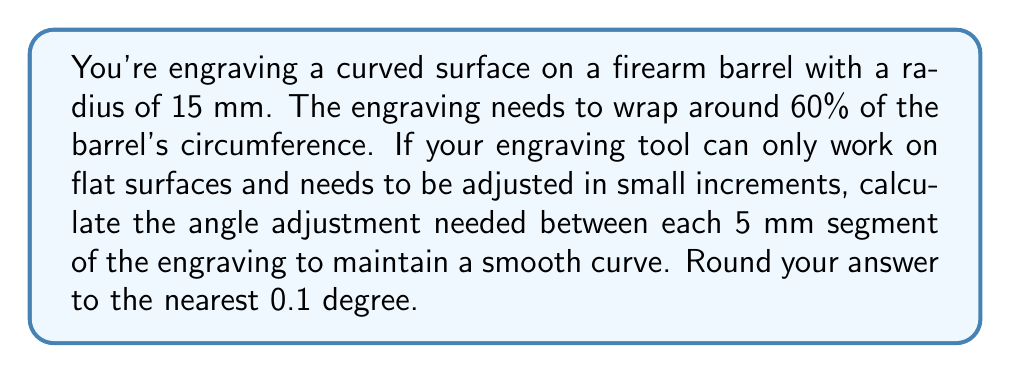Can you answer this question? To solve this problem, we need to follow these steps:

1) First, calculate the total arc length of the engraving:
   Circumference of barrel = $2\pi r = 2\pi(15) = 30\pi$ mm
   60% of circumference = $0.6 \times 30\pi = 18\pi$ mm

2) We need to divide this into 5 mm segments. Calculate the number of segments:
   Number of segments = $\frac{18\pi}{5} = 3.6\pi \approx 11.31$
   We'll round this to 11 segments for practical purposes.

3) Now, we need to find the central angle corresponding to these 11 segments:
   Total central angle = $0.6 \times 360° = 216°$ (since the engraving covers 60% of the circumference)

4) The angle adjustment between each segment will be:
   Angle per segment = $\frac{216°}{11} = 19.64°$

5) However, this is the central angle. We need the angle adjustment for the engraving tool, which is the complement of half this angle:

   $$\text{Tool adjustment angle} = 90° - \frac{19.64°}{2} = 80.18°$$

Therefore, the angle adjustment needed between each 5 mm segment is approximately 80.2°.

[asy]
import geometry;

size(200);
pair O = (0,0);
real r = 5;
draw(circle(O,r));
draw(O--(-r,0), dashed);
draw(O--(r*cos(19.64), r*sin(19.64)));
draw(arc(O, (-r,0), (r*cos(19.64), r*sin(19.64))), blue);
label("$19.64°$", (0.5r,0.5r), NE);
label("$r$", (0.5r,0), S);
label("O", O, SW);
draw((-r-1,0)--(r+1,0), arrow=Arrow(TeXHead));
draw((0,-r-1)--(0,r+1), arrow=Arrow(TeXHead));
</asy>
Answer: $80.2°$ 